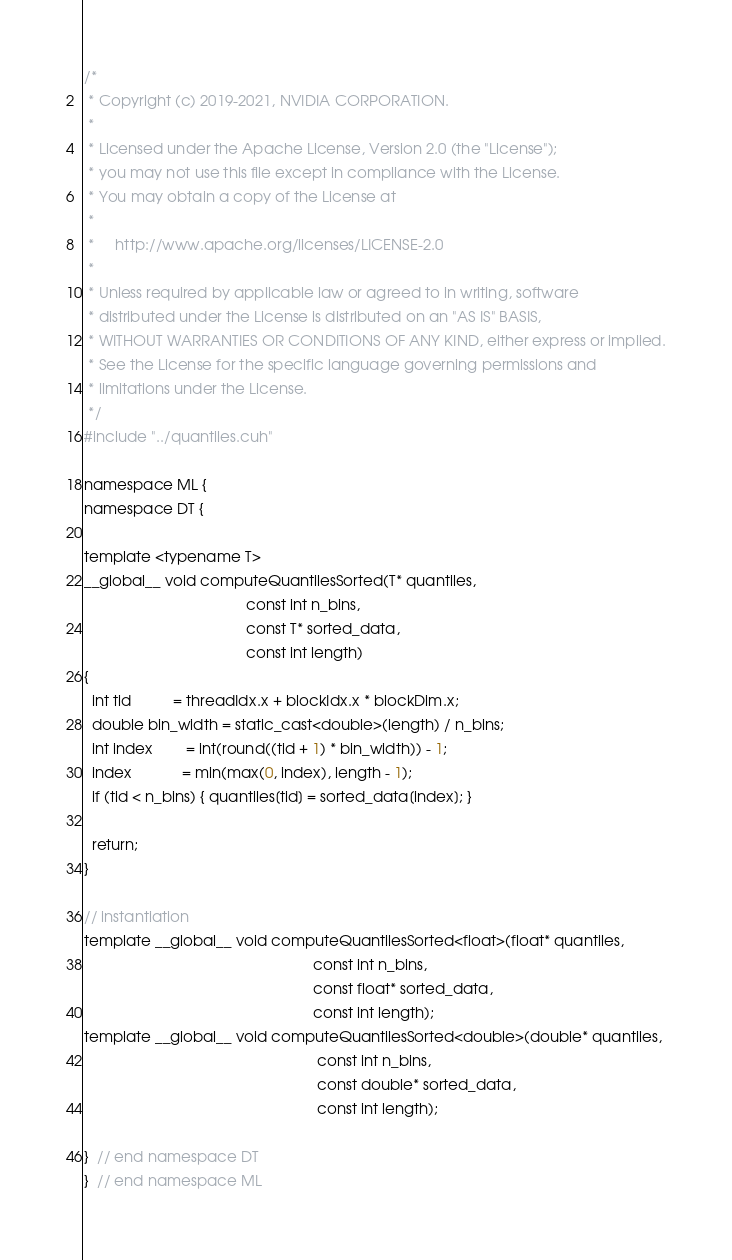Convert code to text. <code><loc_0><loc_0><loc_500><loc_500><_Cuda_>
/*
 * Copyright (c) 2019-2021, NVIDIA CORPORATION.
 *
 * Licensed under the Apache License, Version 2.0 (the "License");
 * you may not use this file except in compliance with the License.
 * You may obtain a copy of the License at
 *
 *     http://www.apache.org/licenses/LICENSE-2.0
 *
 * Unless required by applicable law or agreed to in writing, software
 * distributed under the License is distributed on an "AS IS" BASIS,
 * WITHOUT WARRANTIES OR CONDITIONS OF ANY KIND, either express or implied.
 * See the License for the specific language governing permissions and
 * limitations under the License.
 */
#include "../quantiles.cuh"

namespace ML {
namespace DT {

template <typename T>
__global__ void computeQuantilesSorted(T* quantiles,
                                       const int n_bins,
                                       const T* sorted_data,
                                       const int length)
{
  int tid          = threadIdx.x + blockIdx.x * blockDim.x;
  double bin_width = static_cast<double>(length) / n_bins;
  int index        = int(round((tid + 1) * bin_width)) - 1;
  index            = min(max(0, index), length - 1);
  if (tid < n_bins) { quantiles[tid] = sorted_data[index]; }

  return;
}

// instantiation
template __global__ void computeQuantilesSorted<float>(float* quantiles,
                                                       const int n_bins,
                                                       const float* sorted_data,
                                                       const int length);
template __global__ void computeQuantilesSorted<double>(double* quantiles,
                                                        const int n_bins,
                                                        const double* sorted_data,
                                                        const int length);

}  // end namespace DT
}  // end namespace ML</code> 